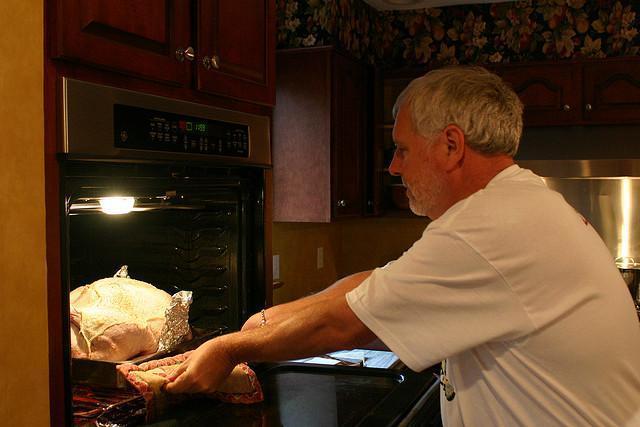How many armbands is the man wearing?
Give a very brief answer. 1. How many cakes are the men cooking?
Give a very brief answer. 0. 